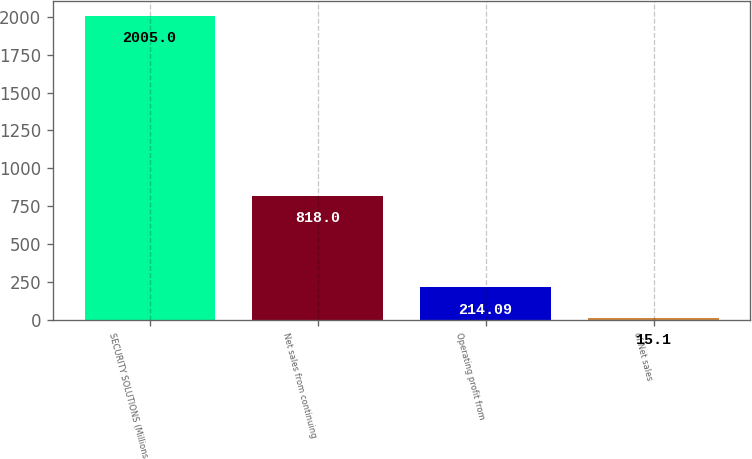Convert chart to OTSL. <chart><loc_0><loc_0><loc_500><loc_500><bar_chart><fcel>SECURITY SOLUTIONS (Millions<fcel>Net sales from continuing<fcel>Operating profit from<fcel>of Net sales<nl><fcel>2005<fcel>818<fcel>214.09<fcel>15.1<nl></chart> 